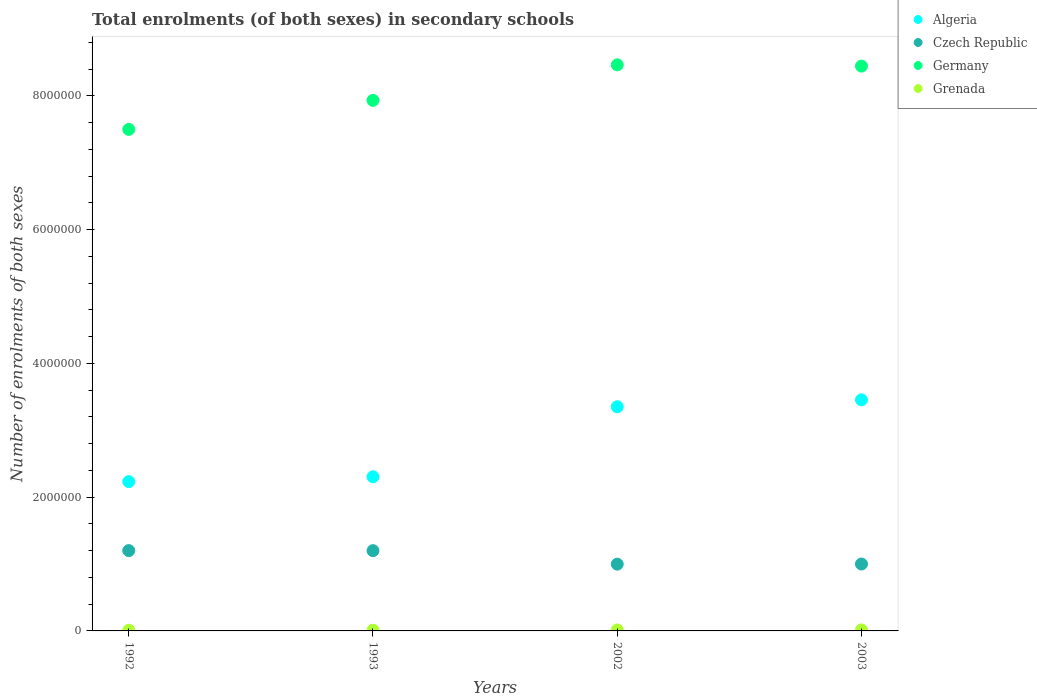How many different coloured dotlines are there?
Provide a short and direct response. 4. Is the number of dotlines equal to the number of legend labels?
Keep it short and to the point. Yes. What is the number of enrolments in secondary schools in Algeria in 2002?
Give a very brief answer. 3.35e+06. Across all years, what is the maximum number of enrolments in secondary schools in Czech Republic?
Offer a very short reply. 1.20e+06. Across all years, what is the minimum number of enrolments in secondary schools in Czech Republic?
Keep it short and to the point. 9.99e+05. In which year was the number of enrolments in secondary schools in Czech Republic minimum?
Make the answer very short. 2002. What is the total number of enrolments in secondary schools in Germany in the graph?
Your answer should be compact. 3.23e+07. What is the difference between the number of enrolments in secondary schools in Czech Republic in 1992 and that in 1993?
Ensure brevity in your answer.  889. What is the difference between the number of enrolments in secondary schools in Grenada in 1993 and the number of enrolments in secondary schools in Czech Republic in 2002?
Give a very brief answer. -9.88e+05. What is the average number of enrolments in secondary schools in Czech Republic per year?
Provide a short and direct response. 1.10e+06. In the year 1993, what is the difference between the number of enrolments in secondary schools in Grenada and number of enrolments in secondary schools in Algeria?
Provide a short and direct response. -2.29e+06. In how many years, is the number of enrolments in secondary schools in Germany greater than 800000?
Your response must be concise. 4. What is the ratio of the number of enrolments in secondary schools in Algeria in 1992 to that in 2003?
Provide a short and direct response. 0.65. Is the number of enrolments in secondary schools in Grenada in 1993 less than that in 2002?
Offer a terse response. Yes. What is the difference between the highest and the second highest number of enrolments in secondary schools in Algeria?
Your answer should be compact. 1.04e+05. What is the difference between the highest and the lowest number of enrolments in secondary schools in Germany?
Make the answer very short. 9.65e+05. In how many years, is the number of enrolments in secondary schools in Grenada greater than the average number of enrolments in secondary schools in Grenada taken over all years?
Offer a terse response. 2. Is the sum of the number of enrolments in secondary schools in Grenada in 1992 and 2003 greater than the maximum number of enrolments in secondary schools in Czech Republic across all years?
Provide a short and direct response. No. Is it the case that in every year, the sum of the number of enrolments in secondary schools in Germany and number of enrolments in secondary schools in Algeria  is greater than the number of enrolments in secondary schools in Czech Republic?
Offer a terse response. Yes. Is the number of enrolments in secondary schools in Algeria strictly less than the number of enrolments in secondary schools in Czech Republic over the years?
Your answer should be compact. No. How many years are there in the graph?
Offer a very short reply. 4. Does the graph contain any zero values?
Offer a very short reply. No. Does the graph contain grids?
Your answer should be compact. No. How many legend labels are there?
Ensure brevity in your answer.  4. How are the legend labels stacked?
Your response must be concise. Vertical. What is the title of the graph?
Your answer should be compact. Total enrolments (of both sexes) in secondary schools. Does "Czech Republic" appear as one of the legend labels in the graph?
Keep it short and to the point. Yes. What is the label or title of the Y-axis?
Keep it short and to the point. Number of enrolments of both sexes. What is the Number of enrolments of both sexes in Algeria in 1992?
Provide a short and direct response. 2.23e+06. What is the Number of enrolments of both sexes of Czech Republic in 1992?
Keep it short and to the point. 1.20e+06. What is the Number of enrolments of both sexes of Germany in 1992?
Keep it short and to the point. 7.50e+06. What is the Number of enrolments of both sexes of Grenada in 1992?
Your answer should be very brief. 9896. What is the Number of enrolments of both sexes in Algeria in 1993?
Give a very brief answer. 2.31e+06. What is the Number of enrolments of both sexes in Czech Republic in 1993?
Your response must be concise. 1.20e+06. What is the Number of enrolments of both sexes of Germany in 1993?
Keep it short and to the point. 7.93e+06. What is the Number of enrolments of both sexes of Grenada in 1993?
Offer a terse response. 1.02e+04. What is the Number of enrolments of both sexes of Algeria in 2002?
Your answer should be compact. 3.35e+06. What is the Number of enrolments of both sexes of Czech Republic in 2002?
Make the answer very short. 9.99e+05. What is the Number of enrolments of both sexes of Germany in 2002?
Your answer should be compact. 8.47e+06. What is the Number of enrolments of both sexes of Grenada in 2002?
Ensure brevity in your answer.  1.45e+04. What is the Number of enrolments of both sexes in Algeria in 2003?
Provide a succinct answer. 3.46e+06. What is the Number of enrolments of both sexes in Czech Republic in 2003?
Offer a very short reply. 1.00e+06. What is the Number of enrolments of both sexes in Germany in 2003?
Give a very brief answer. 8.45e+06. What is the Number of enrolments of both sexes of Grenada in 2003?
Give a very brief answer. 1.49e+04. Across all years, what is the maximum Number of enrolments of both sexes in Algeria?
Offer a very short reply. 3.46e+06. Across all years, what is the maximum Number of enrolments of both sexes in Czech Republic?
Ensure brevity in your answer.  1.20e+06. Across all years, what is the maximum Number of enrolments of both sexes of Germany?
Provide a short and direct response. 8.47e+06. Across all years, what is the maximum Number of enrolments of both sexes of Grenada?
Make the answer very short. 1.49e+04. Across all years, what is the minimum Number of enrolments of both sexes in Algeria?
Offer a terse response. 2.23e+06. Across all years, what is the minimum Number of enrolments of both sexes in Czech Republic?
Give a very brief answer. 9.99e+05. Across all years, what is the minimum Number of enrolments of both sexes in Germany?
Offer a very short reply. 7.50e+06. Across all years, what is the minimum Number of enrolments of both sexes of Grenada?
Provide a succinct answer. 9896. What is the total Number of enrolments of both sexes of Algeria in the graph?
Make the answer very short. 1.13e+07. What is the total Number of enrolments of both sexes of Czech Republic in the graph?
Provide a succinct answer. 4.40e+06. What is the total Number of enrolments of both sexes in Germany in the graph?
Ensure brevity in your answer.  3.23e+07. What is the total Number of enrolments of both sexes of Grenada in the graph?
Give a very brief answer. 4.94e+04. What is the difference between the Number of enrolments of both sexes in Algeria in 1992 and that in 1993?
Make the answer very short. -7.24e+04. What is the difference between the Number of enrolments of both sexes of Czech Republic in 1992 and that in 1993?
Offer a very short reply. 889. What is the difference between the Number of enrolments of both sexes in Germany in 1992 and that in 1993?
Provide a short and direct response. -4.34e+05. What is the difference between the Number of enrolments of both sexes of Grenada in 1992 and that in 1993?
Offer a terse response. -317. What is the difference between the Number of enrolments of both sexes of Algeria in 1992 and that in 2002?
Your answer should be compact. -1.12e+06. What is the difference between the Number of enrolments of both sexes of Czech Republic in 1992 and that in 2002?
Ensure brevity in your answer.  2.03e+05. What is the difference between the Number of enrolments of both sexes of Germany in 1992 and that in 2002?
Your answer should be very brief. -9.65e+05. What is the difference between the Number of enrolments of both sexes of Grenada in 1992 and that in 2002?
Keep it short and to the point. -4571. What is the difference between the Number of enrolments of both sexes of Algeria in 1992 and that in 2003?
Make the answer very short. -1.22e+06. What is the difference between the Number of enrolments of both sexes of Czech Republic in 1992 and that in 2003?
Your answer should be very brief. 2.01e+05. What is the difference between the Number of enrolments of both sexes in Germany in 1992 and that in 2003?
Make the answer very short. -9.46e+05. What is the difference between the Number of enrolments of both sexes of Grenada in 1992 and that in 2003?
Ensure brevity in your answer.  -4964. What is the difference between the Number of enrolments of both sexes in Algeria in 1993 and that in 2002?
Offer a terse response. -1.05e+06. What is the difference between the Number of enrolments of both sexes in Czech Republic in 1993 and that in 2002?
Give a very brief answer. 2.02e+05. What is the difference between the Number of enrolments of both sexes of Germany in 1993 and that in 2002?
Provide a succinct answer. -5.31e+05. What is the difference between the Number of enrolments of both sexes of Grenada in 1993 and that in 2002?
Ensure brevity in your answer.  -4254. What is the difference between the Number of enrolments of both sexes of Algeria in 1993 and that in 2003?
Provide a short and direct response. -1.15e+06. What is the difference between the Number of enrolments of both sexes in Czech Republic in 1993 and that in 2003?
Your answer should be compact. 2.00e+05. What is the difference between the Number of enrolments of both sexes in Germany in 1993 and that in 2003?
Your response must be concise. -5.13e+05. What is the difference between the Number of enrolments of both sexes in Grenada in 1993 and that in 2003?
Provide a succinct answer. -4647. What is the difference between the Number of enrolments of both sexes of Algeria in 2002 and that in 2003?
Offer a very short reply. -1.04e+05. What is the difference between the Number of enrolments of both sexes in Czech Republic in 2002 and that in 2003?
Keep it short and to the point. -1885. What is the difference between the Number of enrolments of both sexes in Germany in 2002 and that in 2003?
Your answer should be very brief. 1.86e+04. What is the difference between the Number of enrolments of both sexes in Grenada in 2002 and that in 2003?
Ensure brevity in your answer.  -393. What is the difference between the Number of enrolments of both sexes in Algeria in 1992 and the Number of enrolments of both sexes in Czech Republic in 1993?
Your response must be concise. 1.03e+06. What is the difference between the Number of enrolments of both sexes of Algeria in 1992 and the Number of enrolments of both sexes of Germany in 1993?
Keep it short and to the point. -5.70e+06. What is the difference between the Number of enrolments of both sexes of Algeria in 1992 and the Number of enrolments of both sexes of Grenada in 1993?
Ensure brevity in your answer.  2.22e+06. What is the difference between the Number of enrolments of both sexes of Czech Republic in 1992 and the Number of enrolments of both sexes of Germany in 1993?
Give a very brief answer. -6.73e+06. What is the difference between the Number of enrolments of both sexes in Czech Republic in 1992 and the Number of enrolments of both sexes in Grenada in 1993?
Provide a succinct answer. 1.19e+06. What is the difference between the Number of enrolments of both sexes in Germany in 1992 and the Number of enrolments of both sexes in Grenada in 1993?
Provide a short and direct response. 7.49e+06. What is the difference between the Number of enrolments of both sexes in Algeria in 1992 and the Number of enrolments of both sexes in Czech Republic in 2002?
Your response must be concise. 1.23e+06. What is the difference between the Number of enrolments of both sexes in Algeria in 1992 and the Number of enrolments of both sexes in Germany in 2002?
Your answer should be compact. -6.23e+06. What is the difference between the Number of enrolments of both sexes of Algeria in 1992 and the Number of enrolments of both sexes of Grenada in 2002?
Give a very brief answer. 2.22e+06. What is the difference between the Number of enrolments of both sexes of Czech Republic in 1992 and the Number of enrolments of both sexes of Germany in 2002?
Your answer should be very brief. -7.26e+06. What is the difference between the Number of enrolments of both sexes of Czech Republic in 1992 and the Number of enrolments of both sexes of Grenada in 2002?
Make the answer very short. 1.19e+06. What is the difference between the Number of enrolments of both sexes in Germany in 1992 and the Number of enrolments of both sexes in Grenada in 2002?
Your answer should be compact. 7.49e+06. What is the difference between the Number of enrolments of both sexes of Algeria in 1992 and the Number of enrolments of both sexes of Czech Republic in 2003?
Make the answer very short. 1.23e+06. What is the difference between the Number of enrolments of both sexes in Algeria in 1992 and the Number of enrolments of both sexes in Germany in 2003?
Offer a terse response. -6.21e+06. What is the difference between the Number of enrolments of both sexes of Algeria in 1992 and the Number of enrolments of both sexes of Grenada in 2003?
Provide a succinct answer. 2.22e+06. What is the difference between the Number of enrolments of both sexes of Czech Republic in 1992 and the Number of enrolments of both sexes of Germany in 2003?
Give a very brief answer. -7.25e+06. What is the difference between the Number of enrolments of both sexes of Czech Republic in 1992 and the Number of enrolments of both sexes of Grenada in 2003?
Your answer should be very brief. 1.19e+06. What is the difference between the Number of enrolments of both sexes in Germany in 1992 and the Number of enrolments of both sexes in Grenada in 2003?
Keep it short and to the point. 7.49e+06. What is the difference between the Number of enrolments of both sexes in Algeria in 1993 and the Number of enrolments of both sexes in Czech Republic in 2002?
Ensure brevity in your answer.  1.31e+06. What is the difference between the Number of enrolments of both sexes in Algeria in 1993 and the Number of enrolments of both sexes in Germany in 2002?
Make the answer very short. -6.16e+06. What is the difference between the Number of enrolments of both sexes in Algeria in 1993 and the Number of enrolments of both sexes in Grenada in 2002?
Provide a succinct answer. 2.29e+06. What is the difference between the Number of enrolments of both sexes in Czech Republic in 1993 and the Number of enrolments of both sexes in Germany in 2002?
Offer a terse response. -7.26e+06. What is the difference between the Number of enrolments of both sexes of Czech Republic in 1993 and the Number of enrolments of both sexes of Grenada in 2002?
Give a very brief answer. 1.19e+06. What is the difference between the Number of enrolments of both sexes in Germany in 1993 and the Number of enrolments of both sexes in Grenada in 2002?
Offer a very short reply. 7.92e+06. What is the difference between the Number of enrolments of both sexes of Algeria in 1993 and the Number of enrolments of both sexes of Czech Republic in 2003?
Provide a short and direct response. 1.30e+06. What is the difference between the Number of enrolments of both sexes of Algeria in 1993 and the Number of enrolments of both sexes of Germany in 2003?
Ensure brevity in your answer.  -6.14e+06. What is the difference between the Number of enrolments of both sexes in Algeria in 1993 and the Number of enrolments of both sexes in Grenada in 2003?
Offer a very short reply. 2.29e+06. What is the difference between the Number of enrolments of both sexes in Czech Republic in 1993 and the Number of enrolments of both sexes in Germany in 2003?
Give a very brief answer. -7.25e+06. What is the difference between the Number of enrolments of both sexes in Czech Republic in 1993 and the Number of enrolments of both sexes in Grenada in 2003?
Offer a very short reply. 1.19e+06. What is the difference between the Number of enrolments of both sexes of Germany in 1993 and the Number of enrolments of both sexes of Grenada in 2003?
Provide a short and direct response. 7.92e+06. What is the difference between the Number of enrolments of both sexes in Algeria in 2002 and the Number of enrolments of both sexes in Czech Republic in 2003?
Give a very brief answer. 2.35e+06. What is the difference between the Number of enrolments of both sexes of Algeria in 2002 and the Number of enrolments of both sexes of Germany in 2003?
Offer a terse response. -5.09e+06. What is the difference between the Number of enrolments of both sexes in Algeria in 2002 and the Number of enrolments of both sexes in Grenada in 2003?
Make the answer very short. 3.34e+06. What is the difference between the Number of enrolments of both sexes in Czech Republic in 2002 and the Number of enrolments of both sexes in Germany in 2003?
Provide a succinct answer. -7.45e+06. What is the difference between the Number of enrolments of both sexes in Czech Republic in 2002 and the Number of enrolments of both sexes in Grenada in 2003?
Your response must be concise. 9.84e+05. What is the difference between the Number of enrolments of both sexes of Germany in 2002 and the Number of enrolments of both sexes of Grenada in 2003?
Offer a very short reply. 8.45e+06. What is the average Number of enrolments of both sexes of Algeria per year?
Your answer should be compact. 2.84e+06. What is the average Number of enrolments of both sexes in Czech Republic per year?
Your answer should be very brief. 1.10e+06. What is the average Number of enrolments of both sexes of Germany per year?
Give a very brief answer. 8.09e+06. What is the average Number of enrolments of both sexes of Grenada per year?
Your response must be concise. 1.24e+04. In the year 1992, what is the difference between the Number of enrolments of both sexes in Algeria and Number of enrolments of both sexes in Czech Republic?
Provide a succinct answer. 1.03e+06. In the year 1992, what is the difference between the Number of enrolments of both sexes in Algeria and Number of enrolments of both sexes in Germany?
Offer a terse response. -5.27e+06. In the year 1992, what is the difference between the Number of enrolments of both sexes of Algeria and Number of enrolments of both sexes of Grenada?
Your answer should be very brief. 2.22e+06. In the year 1992, what is the difference between the Number of enrolments of both sexes in Czech Republic and Number of enrolments of both sexes in Germany?
Make the answer very short. -6.30e+06. In the year 1992, what is the difference between the Number of enrolments of both sexes of Czech Republic and Number of enrolments of both sexes of Grenada?
Make the answer very short. 1.19e+06. In the year 1992, what is the difference between the Number of enrolments of both sexes of Germany and Number of enrolments of both sexes of Grenada?
Make the answer very short. 7.49e+06. In the year 1993, what is the difference between the Number of enrolments of both sexes in Algeria and Number of enrolments of both sexes in Czech Republic?
Provide a succinct answer. 1.10e+06. In the year 1993, what is the difference between the Number of enrolments of both sexes of Algeria and Number of enrolments of both sexes of Germany?
Ensure brevity in your answer.  -5.63e+06. In the year 1993, what is the difference between the Number of enrolments of both sexes in Algeria and Number of enrolments of both sexes in Grenada?
Make the answer very short. 2.29e+06. In the year 1993, what is the difference between the Number of enrolments of both sexes of Czech Republic and Number of enrolments of both sexes of Germany?
Provide a succinct answer. -6.73e+06. In the year 1993, what is the difference between the Number of enrolments of both sexes in Czech Republic and Number of enrolments of both sexes in Grenada?
Ensure brevity in your answer.  1.19e+06. In the year 1993, what is the difference between the Number of enrolments of both sexes of Germany and Number of enrolments of both sexes of Grenada?
Provide a short and direct response. 7.92e+06. In the year 2002, what is the difference between the Number of enrolments of both sexes in Algeria and Number of enrolments of both sexes in Czech Republic?
Keep it short and to the point. 2.35e+06. In the year 2002, what is the difference between the Number of enrolments of both sexes of Algeria and Number of enrolments of both sexes of Germany?
Provide a succinct answer. -5.11e+06. In the year 2002, what is the difference between the Number of enrolments of both sexes of Algeria and Number of enrolments of both sexes of Grenada?
Provide a short and direct response. 3.34e+06. In the year 2002, what is the difference between the Number of enrolments of both sexes of Czech Republic and Number of enrolments of both sexes of Germany?
Provide a short and direct response. -7.47e+06. In the year 2002, what is the difference between the Number of enrolments of both sexes of Czech Republic and Number of enrolments of both sexes of Grenada?
Provide a short and direct response. 9.84e+05. In the year 2002, what is the difference between the Number of enrolments of both sexes in Germany and Number of enrolments of both sexes in Grenada?
Provide a short and direct response. 8.45e+06. In the year 2003, what is the difference between the Number of enrolments of both sexes in Algeria and Number of enrolments of both sexes in Czech Republic?
Your answer should be very brief. 2.46e+06. In the year 2003, what is the difference between the Number of enrolments of both sexes in Algeria and Number of enrolments of both sexes in Germany?
Offer a very short reply. -4.99e+06. In the year 2003, what is the difference between the Number of enrolments of both sexes of Algeria and Number of enrolments of both sexes of Grenada?
Ensure brevity in your answer.  3.44e+06. In the year 2003, what is the difference between the Number of enrolments of both sexes in Czech Republic and Number of enrolments of both sexes in Germany?
Provide a short and direct response. -7.45e+06. In the year 2003, what is the difference between the Number of enrolments of both sexes in Czech Republic and Number of enrolments of both sexes in Grenada?
Offer a terse response. 9.86e+05. In the year 2003, what is the difference between the Number of enrolments of both sexes of Germany and Number of enrolments of both sexes of Grenada?
Offer a terse response. 8.43e+06. What is the ratio of the Number of enrolments of both sexes of Algeria in 1992 to that in 1993?
Your response must be concise. 0.97. What is the ratio of the Number of enrolments of both sexes of Czech Republic in 1992 to that in 1993?
Make the answer very short. 1. What is the ratio of the Number of enrolments of both sexes of Germany in 1992 to that in 1993?
Offer a very short reply. 0.95. What is the ratio of the Number of enrolments of both sexes of Algeria in 1992 to that in 2002?
Your answer should be very brief. 0.67. What is the ratio of the Number of enrolments of both sexes in Czech Republic in 1992 to that in 2002?
Provide a short and direct response. 1.2. What is the ratio of the Number of enrolments of both sexes in Germany in 1992 to that in 2002?
Provide a short and direct response. 0.89. What is the ratio of the Number of enrolments of both sexes of Grenada in 1992 to that in 2002?
Give a very brief answer. 0.68. What is the ratio of the Number of enrolments of both sexes of Algeria in 1992 to that in 2003?
Ensure brevity in your answer.  0.65. What is the ratio of the Number of enrolments of both sexes in Czech Republic in 1992 to that in 2003?
Your answer should be compact. 1.2. What is the ratio of the Number of enrolments of both sexes in Germany in 1992 to that in 2003?
Give a very brief answer. 0.89. What is the ratio of the Number of enrolments of both sexes of Grenada in 1992 to that in 2003?
Offer a terse response. 0.67. What is the ratio of the Number of enrolments of both sexes of Algeria in 1993 to that in 2002?
Your answer should be compact. 0.69. What is the ratio of the Number of enrolments of both sexes in Czech Republic in 1993 to that in 2002?
Offer a terse response. 1.2. What is the ratio of the Number of enrolments of both sexes of Germany in 1993 to that in 2002?
Offer a very short reply. 0.94. What is the ratio of the Number of enrolments of both sexes of Grenada in 1993 to that in 2002?
Make the answer very short. 0.71. What is the ratio of the Number of enrolments of both sexes of Algeria in 1993 to that in 2003?
Provide a succinct answer. 0.67. What is the ratio of the Number of enrolments of both sexes in Czech Republic in 1993 to that in 2003?
Offer a very short reply. 1.2. What is the ratio of the Number of enrolments of both sexes in Germany in 1993 to that in 2003?
Make the answer very short. 0.94. What is the ratio of the Number of enrolments of both sexes of Grenada in 1993 to that in 2003?
Make the answer very short. 0.69. What is the ratio of the Number of enrolments of both sexes in Germany in 2002 to that in 2003?
Ensure brevity in your answer.  1. What is the ratio of the Number of enrolments of both sexes in Grenada in 2002 to that in 2003?
Make the answer very short. 0.97. What is the difference between the highest and the second highest Number of enrolments of both sexes in Algeria?
Your response must be concise. 1.04e+05. What is the difference between the highest and the second highest Number of enrolments of both sexes in Czech Republic?
Ensure brevity in your answer.  889. What is the difference between the highest and the second highest Number of enrolments of both sexes in Germany?
Provide a succinct answer. 1.86e+04. What is the difference between the highest and the second highest Number of enrolments of both sexes in Grenada?
Offer a very short reply. 393. What is the difference between the highest and the lowest Number of enrolments of both sexes in Algeria?
Offer a very short reply. 1.22e+06. What is the difference between the highest and the lowest Number of enrolments of both sexes in Czech Republic?
Your answer should be very brief. 2.03e+05. What is the difference between the highest and the lowest Number of enrolments of both sexes in Germany?
Provide a succinct answer. 9.65e+05. What is the difference between the highest and the lowest Number of enrolments of both sexes in Grenada?
Offer a very short reply. 4964. 